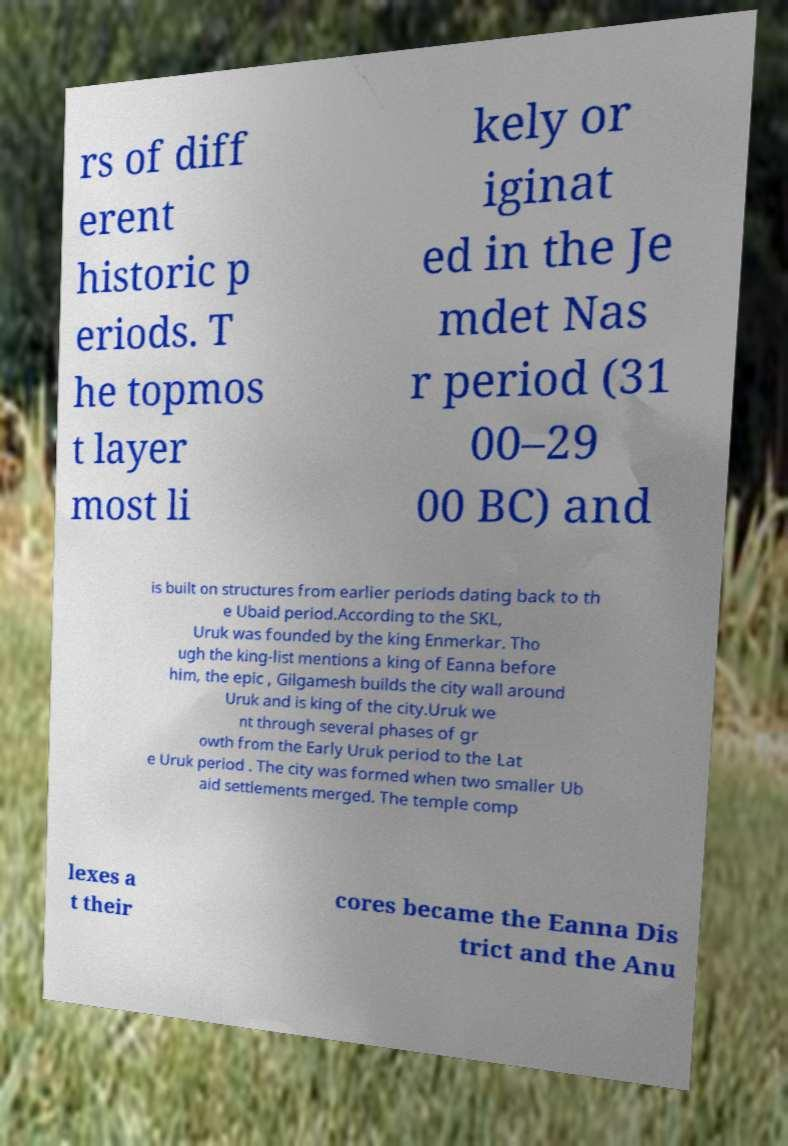Could you assist in decoding the text presented in this image and type it out clearly? rs of diff erent historic p eriods. T he topmos t layer most li kely or iginat ed in the Je mdet Nas r period (31 00–29 00 BC) and is built on structures from earlier periods dating back to th e Ubaid period.According to the SKL, Uruk was founded by the king Enmerkar. Tho ugh the king-list mentions a king of Eanna before him, the epic , Gilgamesh builds the city wall around Uruk and is king of the city.Uruk we nt through several phases of gr owth from the Early Uruk period to the Lat e Uruk period . The city was formed when two smaller Ub aid settlements merged. The temple comp lexes a t their cores became the Eanna Dis trict and the Anu 